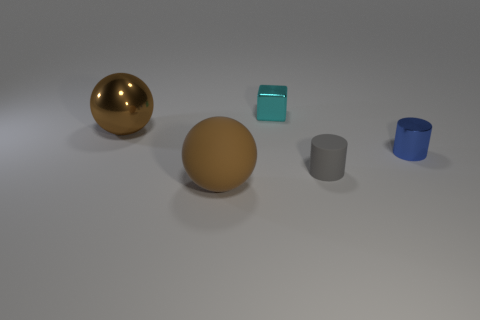Subtract all balls. How many objects are left? 3 Subtract 1 spheres. How many spheres are left? 1 Add 4 large brown spheres. How many large brown spheres are left? 6 Add 3 large objects. How many large objects exist? 5 Add 1 cylinders. How many objects exist? 6 Subtract all gray cylinders. How many cylinders are left? 1 Subtract 0 purple spheres. How many objects are left? 5 Subtract all cyan spheres. Subtract all yellow cylinders. How many spheres are left? 2 Subtract all gray blocks. How many yellow spheres are left? 0 Subtract all tiny green metal spheres. Subtract all small cyan metal blocks. How many objects are left? 4 